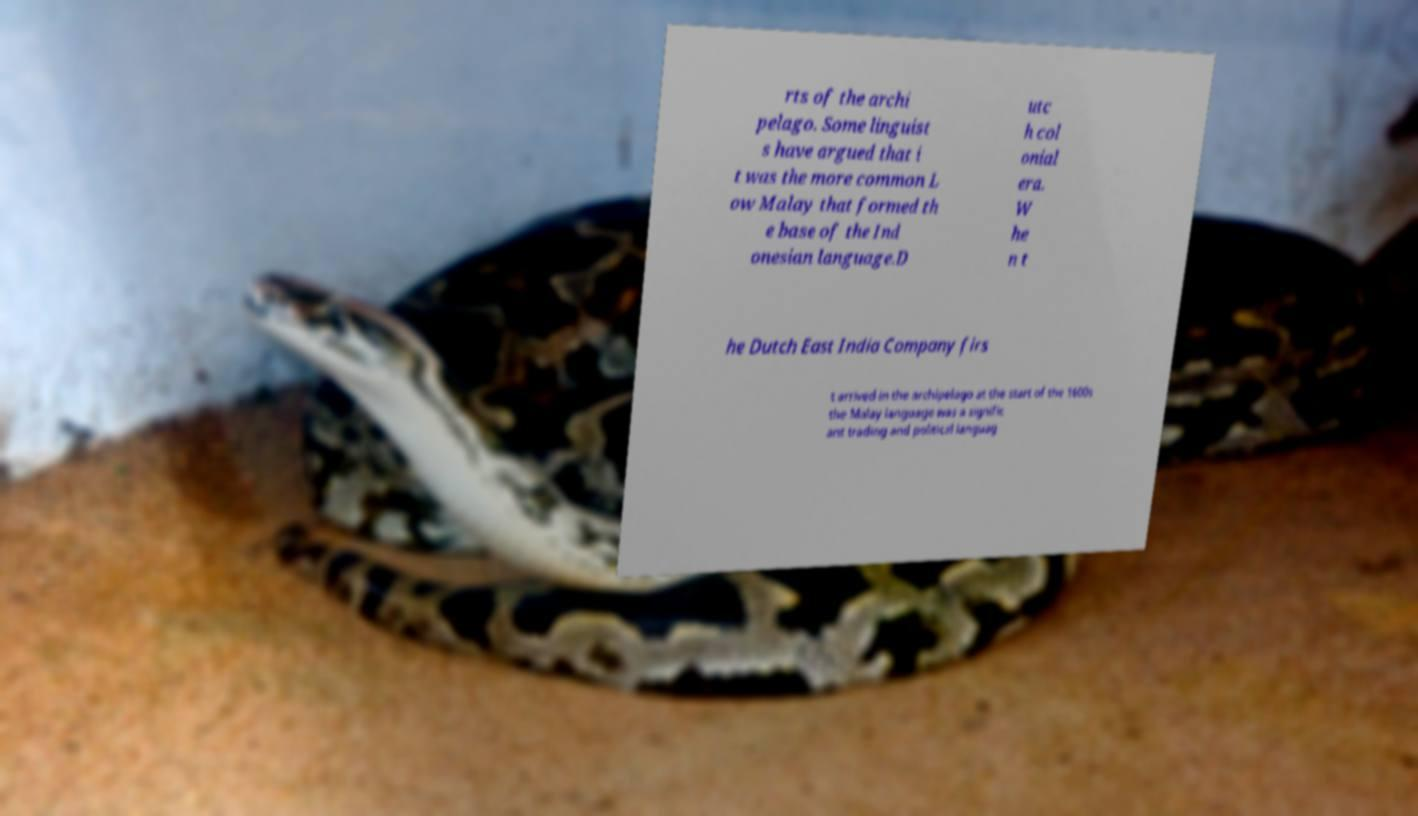Can you accurately transcribe the text from the provided image for me? rts of the archi pelago. Some linguist s have argued that i t was the more common L ow Malay that formed th e base of the Ind onesian language.D utc h col onial era. W he n t he Dutch East India Company firs t arrived in the archipelago at the start of the 1600s the Malay language was a signific ant trading and political languag 